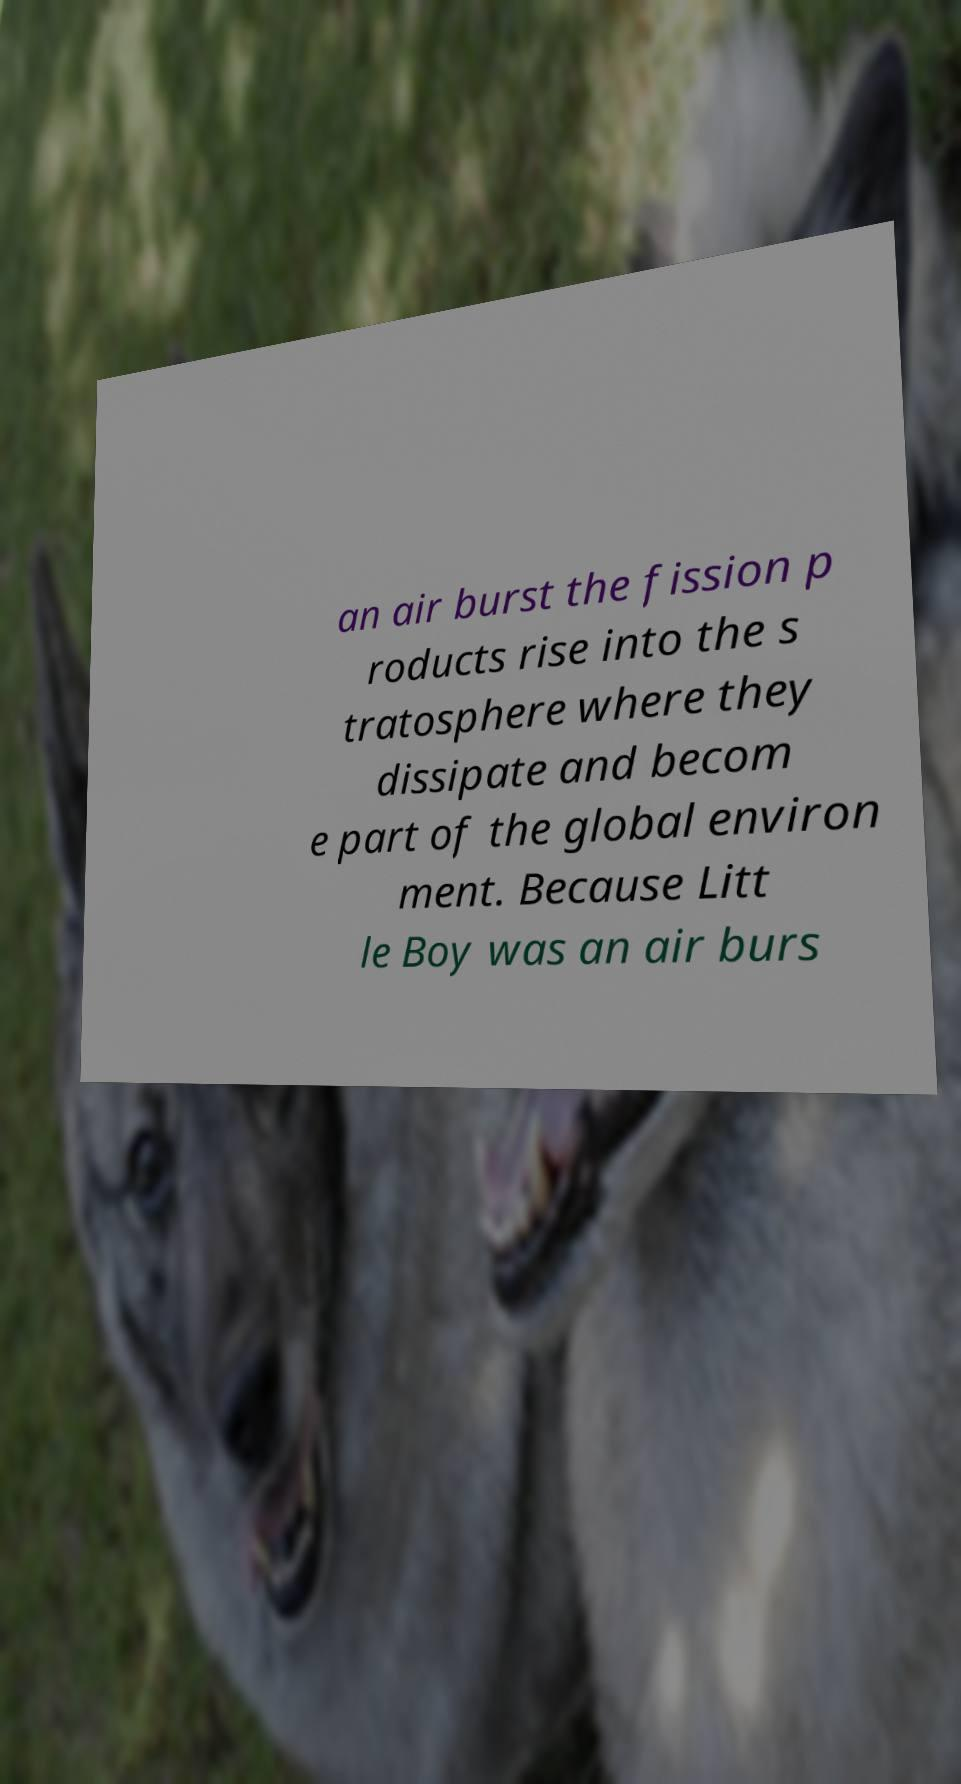Please identify and transcribe the text found in this image. an air burst the fission p roducts rise into the s tratosphere where they dissipate and becom e part of the global environ ment. Because Litt le Boy was an air burs 